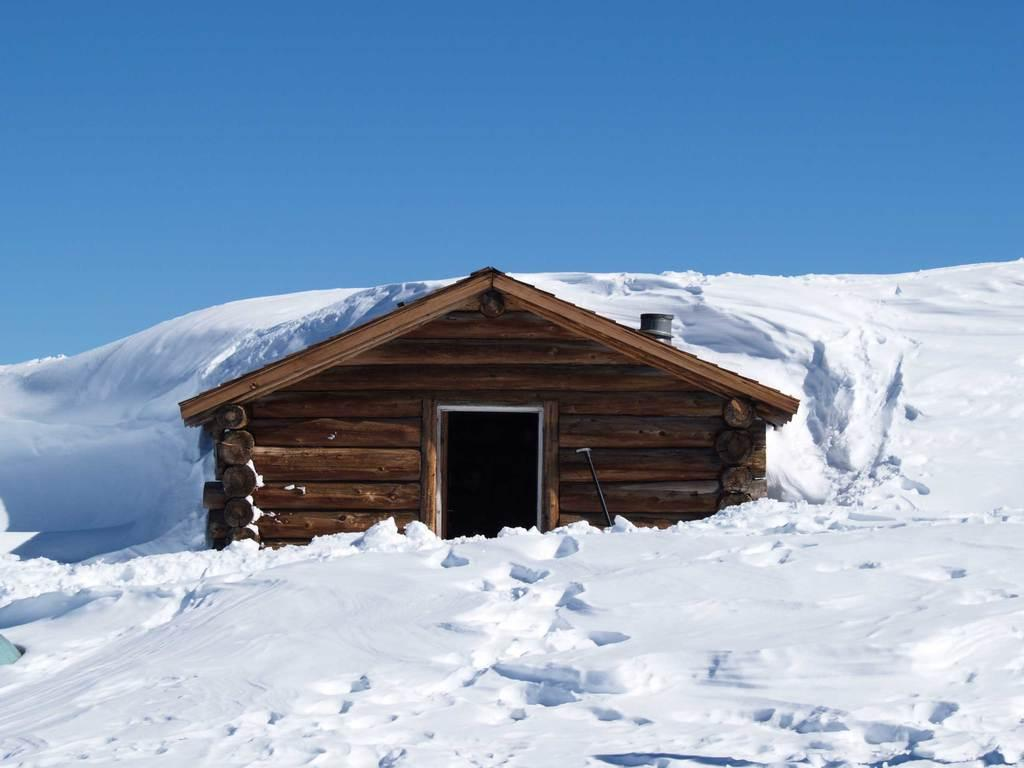What is the weather like in the image? There is snow in the image, indicating a cold and wintry scene. What type of structure can be seen in the image? There is a wooden house in the image. What can be seen in the background of the image? The sky is visible in the background of the image. What is the opinion of the snow in the image? The image does not express an opinion about the snow; it simply depicts the snow as a factual element of the scene. 